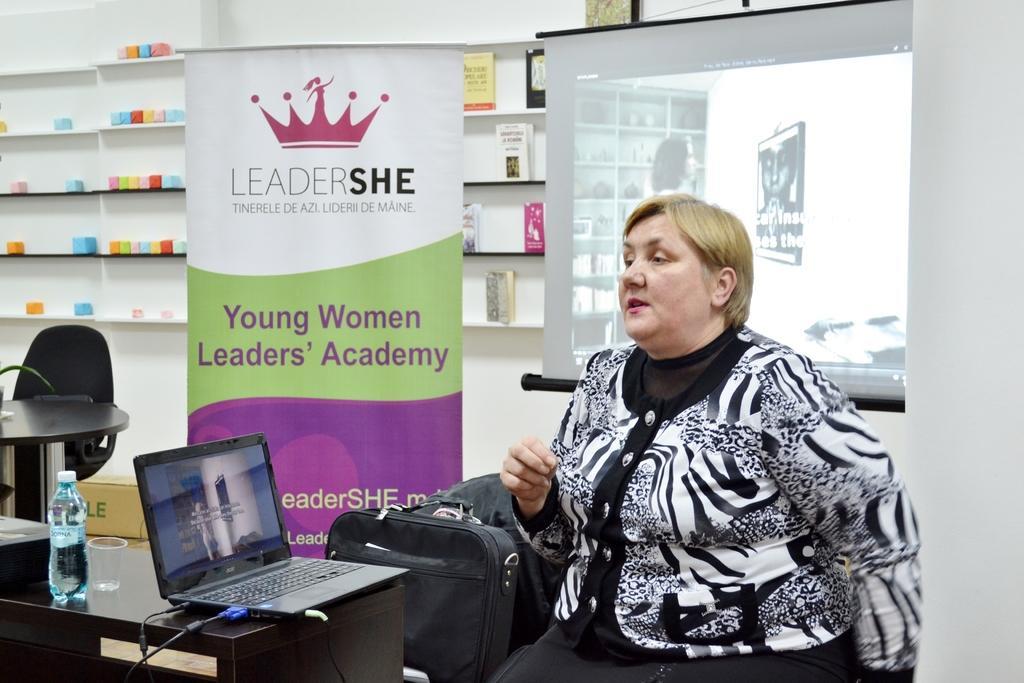Could you give a brief overview of what you see in this image? In this picture we can see woman sitting and talking to someone in front of her we can see laptop, bottle, glass and beside to her we can see bag, banner and back of her we have a screen, racks with cards, some items and here we can see table and chair. 